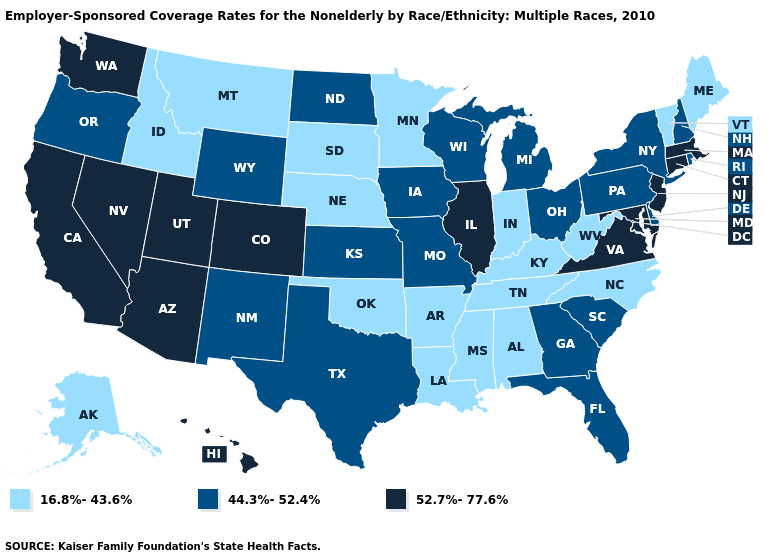What is the highest value in the West ?
Keep it brief. 52.7%-77.6%. Does the map have missing data?
Concise answer only. No. What is the value of Iowa?
Concise answer only. 44.3%-52.4%. Among the states that border Iowa , does Nebraska have the lowest value?
Quick response, please. Yes. Among the states that border North Carolina , which have the lowest value?
Quick response, please. Tennessee. What is the value of North Carolina?
Keep it brief. 16.8%-43.6%. Does Illinois have the highest value in the USA?
Write a very short answer. Yes. What is the value of Nevada?
Be succinct. 52.7%-77.6%. Name the states that have a value in the range 44.3%-52.4%?
Answer briefly. Delaware, Florida, Georgia, Iowa, Kansas, Michigan, Missouri, New Hampshire, New Mexico, New York, North Dakota, Ohio, Oregon, Pennsylvania, Rhode Island, South Carolina, Texas, Wisconsin, Wyoming. Name the states that have a value in the range 16.8%-43.6%?
Keep it brief. Alabama, Alaska, Arkansas, Idaho, Indiana, Kentucky, Louisiana, Maine, Minnesota, Mississippi, Montana, Nebraska, North Carolina, Oklahoma, South Dakota, Tennessee, Vermont, West Virginia. Which states have the lowest value in the USA?
Quick response, please. Alabama, Alaska, Arkansas, Idaho, Indiana, Kentucky, Louisiana, Maine, Minnesota, Mississippi, Montana, Nebraska, North Carolina, Oklahoma, South Dakota, Tennessee, Vermont, West Virginia. What is the lowest value in the South?
Write a very short answer. 16.8%-43.6%. Name the states that have a value in the range 52.7%-77.6%?
Answer briefly. Arizona, California, Colorado, Connecticut, Hawaii, Illinois, Maryland, Massachusetts, Nevada, New Jersey, Utah, Virginia, Washington. What is the value of Utah?
Be succinct. 52.7%-77.6%. What is the lowest value in states that border Delaware?
Concise answer only. 44.3%-52.4%. 